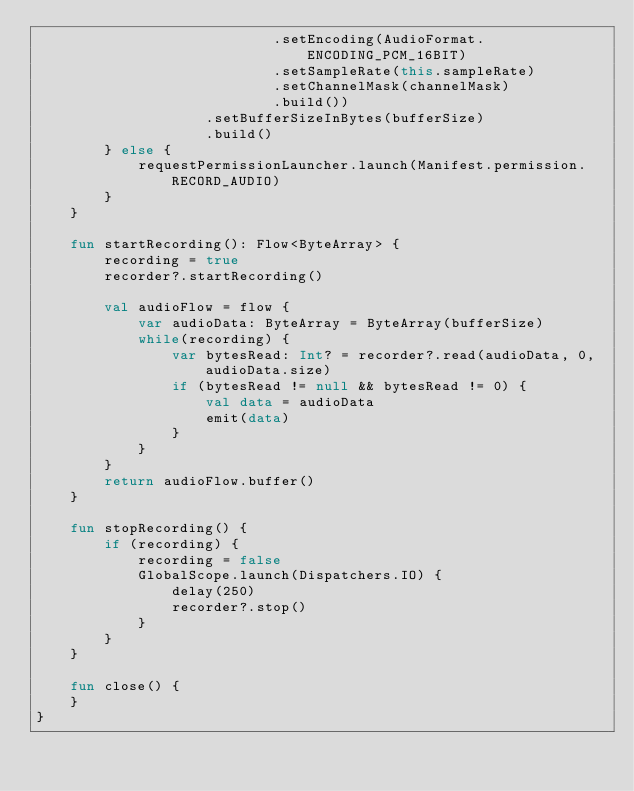<code> <loc_0><loc_0><loc_500><loc_500><_Kotlin_>                            .setEncoding(AudioFormat.ENCODING_PCM_16BIT)
                            .setSampleRate(this.sampleRate)
                            .setChannelMask(channelMask)
                            .build())
                    .setBufferSizeInBytes(bufferSize)
                    .build()
        } else {
            requestPermissionLauncher.launch(Manifest.permission.RECORD_AUDIO)
        }
    }

    fun startRecording(): Flow<ByteArray> {
        recording = true
        recorder?.startRecording()

        val audioFlow = flow {
            var audioData: ByteArray = ByteArray(bufferSize)
            while(recording) {
                var bytesRead: Int? = recorder?.read(audioData, 0, audioData.size)
                if (bytesRead != null && bytesRead != 0) {
                    val data = audioData
                    emit(data)
                }
            }
        }
        return audioFlow.buffer()
    }

    fun stopRecording() {
        if (recording) {
            recording = false
            GlobalScope.launch(Dispatchers.IO) {
                delay(250)
                recorder?.stop()
            }
        }
    }

    fun close() {
    }
}</code> 